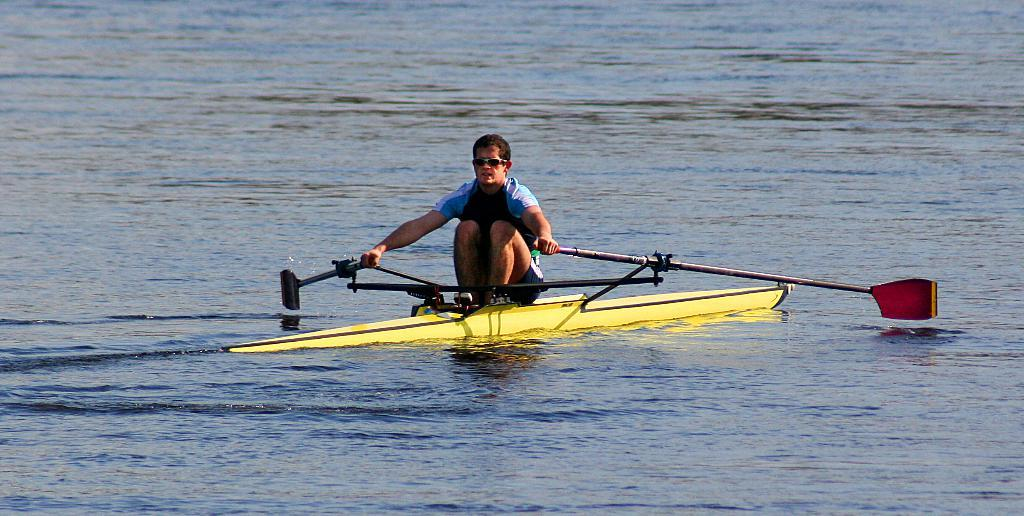Who is the person in the image? There is a man in the image. What is the man doing in the image? The man is rowing in the water. How is the man positioned in the image? The man is sitting on a boat. What type of effect does the band have on the man in the image? There is no band present in the image, so it is not possible to determine any effect they might have on the man. 